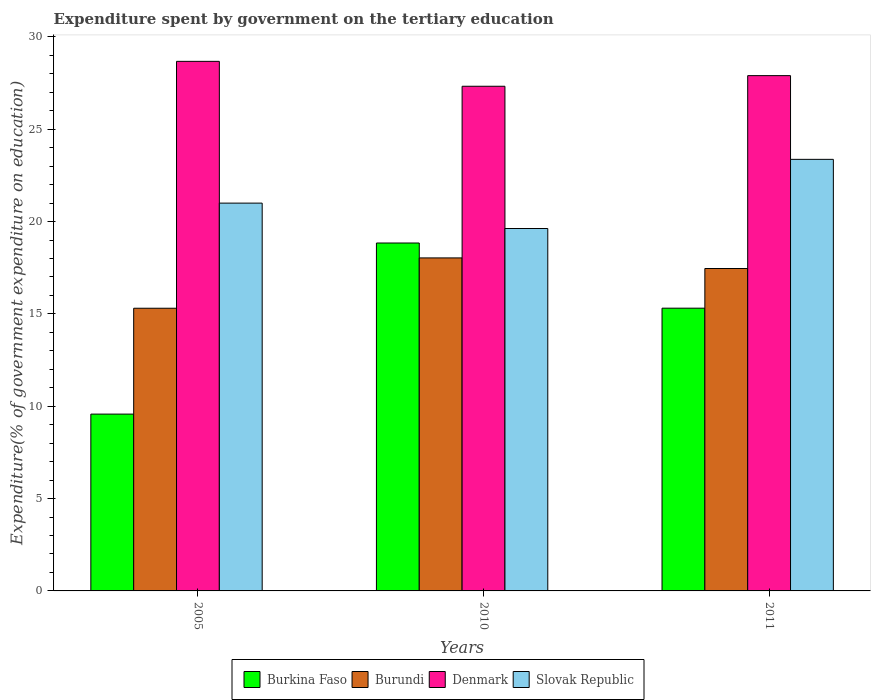How many different coloured bars are there?
Offer a very short reply. 4. Are the number of bars per tick equal to the number of legend labels?
Provide a succinct answer. Yes. Are the number of bars on each tick of the X-axis equal?
Provide a succinct answer. Yes. What is the label of the 2nd group of bars from the left?
Provide a succinct answer. 2010. What is the expenditure spent by government on the tertiary education in Burundi in 2011?
Your response must be concise. 17.46. Across all years, what is the maximum expenditure spent by government on the tertiary education in Slovak Republic?
Provide a short and direct response. 23.37. Across all years, what is the minimum expenditure spent by government on the tertiary education in Denmark?
Offer a very short reply. 27.33. What is the total expenditure spent by government on the tertiary education in Burundi in the graph?
Your response must be concise. 50.8. What is the difference between the expenditure spent by government on the tertiary education in Denmark in 2005 and that in 2011?
Your answer should be compact. 0.77. What is the difference between the expenditure spent by government on the tertiary education in Burundi in 2011 and the expenditure spent by government on the tertiary education in Burkina Faso in 2005?
Offer a very short reply. 7.88. What is the average expenditure spent by government on the tertiary education in Denmark per year?
Your response must be concise. 27.97. In the year 2011, what is the difference between the expenditure spent by government on the tertiary education in Denmark and expenditure spent by government on the tertiary education in Burkina Faso?
Ensure brevity in your answer.  12.59. In how many years, is the expenditure spent by government on the tertiary education in Burkina Faso greater than 5 %?
Your answer should be compact. 3. What is the ratio of the expenditure spent by government on the tertiary education in Burkina Faso in 2005 to that in 2010?
Provide a short and direct response. 0.51. Is the expenditure spent by government on the tertiary education in Denmark in 2005 less than that in 2010?
Provide a succinct answer. No. What is the difference between the highest and the second highest expenditure spent by government on the tertiary education in Slovak Republic?
Ensure brevity in your answer.  2.37. What is the difference between the highest and the lowest expenditure spent by government on the tertiary education in Slovak Republic?
Make the answer very short. 3.74. In how many years, is the expenditure spent by government on the tertiary education in Slovak Republic greater than the average expenditure spent by government on the tertiary education in Slovak Republic taken over all years?
Provide a short and direct response. 1. Is the sum of the expenditure spent by government on the tertiary education in Denmark in 2005 and 2011 greater than the maximum expenditure spent by government on the tertiary education in Burkina Faso across all years?
Offer a terse response. Yes. What does the 2nd bar from the left in 2010 represents?
Ensure brevity in your answer.  Burundi. What does the 4th bar from the right in 2011 represents?
Give a very brief answer. Burkina Faso. Is it the case that in every year, the sum of the expenditure spent by government on the tertiary education in Burkina Faso and expenditure spent by government on the tertiary education in Denmark is greater than the expenditure spent by government on the tertiary education in Slovak Republic?
Your answer should be very brief. Yes. How many years are there in the graph?
Give a very brief answer. 3. What is the difference between two consecutive major ticks on the Y-axis?
Ensure brevity in your answer.  5. Does the graph contain grids?
Your answer should be very brief. No. How many legend labels are there?
Offer a terse response. 4. How are the legend labels stacked?
Keep it short and to the point. Horizontal. What is the title of the graph?
Your answer should be very brief. Expenditure spent by government on the tertiary education. What is the label or title of the Y-axis?
Your answer should be compact. Expenditure(% of government expenditure on education). What is the Expenditure(% of government expenditure on education) in Burkina Faso in 2005?
Give a very brief answer. 9.58. What is the Expenditure(% of government expenditure on education) in Burundi in 2005?
Your response must be concise. 15.31. What is the Expenditure(% of government expenditure on education) in Denmark in 2005?
Ensure brevity in your answer.  28.68. What is the Expenditure(% of government expenditure on education) in Slovak Republic in 2005?
Your answer should be compact. 21. What is the Expenditure(% of government expenditure on education) in Burkina Faso in 2010?
Make the answer very short. 18.84. What is the Expenditure(% of government expenditure on education) of Burundi in 2010?
Your answer should be compact. 18.03. What is the Expenditure(% of government expenditure on education) of Denmark in 2010?
Your response must be concise. 27.33. What is the Expenditure(% of government expenditure on education) of Slovak Republic in 2010?
Keep it short and to the point. 19.63. What is the Expenditure(% of government expenditure on education) in Burkina Faso in 2011?
Keep it short and to the point. 15.31. What is the Expenditure(% of government expenditure on education) in Burundi in 2011?
Your response must be concise. 17.46. What is the Expenditure(% of government expenditure on education) of Denmark in 2011?
Give a very brief answer. 27.9. What is the Expenditure(% of government expenditure on education) of Slovak Republic in 2011?
Offer a terse response. 23.37. Across all years, what is the maximum Expenditure(% of government expenditure on education) in Burkina Faso?
Your response must be concise. 18.84. Across all years, what is the maximum Expenditure(% of government expenditure on education) in Burundi?
Your answer should be compact. 18.03. Across all years, what is the maximum Expenditure(% of government expenditure on education) of Denmark?
Your answer should be very brief. 28.68. Across all years, what is the maximum Expenditure(% of government expenditure on education) in Slovak Republic?
Make the answer very short. 23.37. Across all years, what is the minimum Expenditure(% of government expenditure on education) in Burkina Faso?
Offer a terse response. 9.58. Across all years, what is the minimum Expenditure(% of government expenditure on education) of Burundi?
Your answer should be compact. 15.31. Across all years, what is the minimum Expenditure(% of government expenditure on education) in Denmark?
Make the answer very short. 27.33. Across all years, what is the minimum Expenditure(% of government expenditure on education) of Slovak Republic?
Your response must be concise. 19.63. What is the total Expenditure(% of government expenditure on education) of Burkina Faso in the graph?
Your answer should be compact. 43.73. What is the total Expenditure(% of government expenditure on education) in Burundi in the graph?
Offer a terse response. 50.8. What is the total Expenditure(% of government expenditure on education) of Denmark in the graph?
Provide a short and direct response. 83.91. What is the total Expenditure(% of government expenditure on education) in Slovak Republic in the graph?
Give a very brief answer. 64. What is the difference between the Expenditure(% of government expenditure on education) of Burkina Faso in 2005 and that in 2010?
Provide a succinct answer. -9.27. What is the difference between the Expenditure(% of government expenditure on education) in Burundi in 2005 and that in 2010?
Offer a very short reply. -2.73. What is the difference between the Expenditure(% of government expenditure on education) of Denmark in 2005 and that in 2010?
Provide a succinct answer. 1.35. What is the difference between the Expenditure(% of government expenditure on education) of Slovak Republic in 2005 and that in 2010?
Your answer should be compact. 1.38. What is the difference between the Expenditure(% of government expenditure on education) of Burkina Faso in 2005 and that in 2011?
Provide a short and direct response. -5.74. What is the difference between the Expenditure(% of government expenditure on education) of Burundi in 2005 and that in 2011?
Your answer should be compact. -2.15. What is the difference between the Expenditure(% of government expenditure on education) in Denmark in 2005 and that in 2011?
Keep it short and to the point. 0.77. What is the difference between the Expenditure(% of government expenditure on education) in Slovak Republic in 2005 and that in 2011?
Offer a terse response. -2.37. What is the difference between the Expenditure(% of government expenditure on education) in Burkina Faso in 2010 and that in 2011?
Keep it short and to the point. 3.53. What is the difference between the Expenditure(% of government expenditure on education) in Burundi in 2010 and that in 2011?
Ensure brevity in your answer.  0.57. What is the difference between the Expenditure(% of government expenditure on education) of Denmark in 2010 and that in 2011?
Offer a very short reply. -0.58. What is the difference between the Expenditure(% of government expenditure on education) of Slovak Republic in 2010 and that in 2011?
Ensure brevity in your answer.  -3.74. What is the difference between the Expenditure(% of government expenditure on education) in Burkina Faso in 2005 and the Expenditure(% of government expenditure on education) in Burundi in 2010?
Your answer should be very brief. -8.46. What is the difference between the Expenditure(% of government expenditure on education) in Burkina Faso in 2005 and the Expenditure(% of government expenditure on education) in Denmark in 2010?
Provide a short and direct response. -17.75. What is the difference between the Expenditure(% of government expenditure on education) of Burkina Faso in 2005 and the Expenditure(% of government expenditure on education) of Slovak Republic in 2010?
Keep it short and to the point. -10.05. What is the difference between the Expenditure(% of government expenditure on education) in Burundi in 2005 and the Expenditure(% of government expenditure on education) in Denmark in 2010?
Your answer should be very brief. -12.02. What is the difference between the Expenditure(% of government expenditure on education) in Burundi in 2005 and the Expenditure(% of government expenditure on education) in Slovak Republic in 2010?
Make the answer very short. -4.32. What is the difference between the Expenditure(% of government expenditure on education) of Denmark in 2005 and the Expenditure(% of government expenditure on education) of Slovak Republic in 2010?
Offer a terse response. 9.05. What is the difference between the Expenditure(% of government expenditure on education) of Burkina Faso in 2005 and the Expenditure(% of government expenditure on education) of Burundi in 2011?
Provide a succinct answer. -7.88. What is the difference between the Expenditure(% of government expenditure on education) of Burkina Faso in 2005 and the Expenditure(% of government expenditure on education) of Denmark in 2011?
Provide a succinct answer. -18.33. What is the difference between the Expenditure(% of government expenditure on education) of Burkina Faso in 2005 and the Expenditure(% of government expenditure on education) of Slovak Republic in 2011?
Give a very brief answer. -13.8. What is the difference between the Expenditure(% of government expenditure on education) in Burundi in 2005 and the Expenditure(% of government expenditure on education) in Denmark in 2011?
Provide a succinct answer. -12.6. What is the difference between the Expenditure(% of government expenditure on education) of Burundi in 2005 and the Expenditure(% of government expenditure on education) of Slovak Republic in 2011?
Your answer should be very brief. -8.06. What is the difference between the Expenditure(% of government expenditure on education) of Denmark in 2005 and the Expenditure(% of government expenditure on education) of Slovak Republic in 2011?
Your answer should be very brief. 5.31. What is the difference between the Expenditure(% of government expenditure on education) of Burkina Faso in 2010 and the Expenditure(% of government expenditure on education) of Burundi in 2011?
Your answer should be very brief. 1.38. What is the difference between the Expenditure(% of government expenditure on education) of Burkina Faso in 2010 and the Expenditure(% of government expenditure on education) of Denmark in 2011?
Make the answer very short. -9.06. What is the difference between the Expenditure(% of government expenditure on education) of Burkina Faso in 2010 and the Expenditure(% of government expenditure on education) of Slovak Republic in 2011?
Offer a terse response. -4.53. What is the difference between the Expenditure(% of government expenditure on education) of Burundi in 2010 and the Expenditure(% of government expenditure on education) of Denmark in 2011?
Give a very brief answer. -9.87. What is the difference between the Expenditure(% of government expenditure on education) of Burundi in 2010 and the Expenditure(% of government expenditure on education) of Slovak Republic in 2011?
Your response must be concise. -5.34. What is the difference between the Expenditure(% of government expenditure on education) in Denmark in 2010 and the Expenditure(% of government expenditure on education) in Slovak Republic in 2011?
Provide a short and direct response. 3.96. What is the average Expenditure(% of government expenditure on education) in Burkina Faso per year?
Make the answer very short. 14.58. What is the average Expenditure(% of government expenditure on education) of Burundi per year?
Offer a terse response. 16.93. What is the average Expenditure(% of government expenditure on education) of Denmark per year?
Your response must be concise. 27.97. What is the average Expenditure(% of government expenditure on education) of Slovak Republic per year?
Keep it short and to the point. 21.33. In the year 2005, what is the difference between the Expenditure(% of government expenditure on education) of Burkina Faso and Expenditure(% of government expenditure on education) of Burundi?
Offer a terse response. -5.73. In the year 2005, what is the difference between the Expenditure(% of government expenditure on education) of Burkina Faso and Expenditure(% of government expenditure on education) of Denmark?
Give a very brief answer. -19.1. In the year 2005, what is the difference between the Expenditure(% of government expenditure on education) in Burkina Faso and Expenditure(% of government expenditure on education) in Slovak Republic?
Provide a succinct answer. -11.43. In the year 2005, what is the difference between the Expenditure(% of government expenditure on education) of Burundi and Expenditure(% of government expenditure on education) of Denmark?
Your answer should be very brief. -13.37. In the year 2005, what is the difference between the Expenditure(% of government expenditure on education) of Burundi and Expenditure(% of government expenditure on education) of Slovak Republic?
Make the answer very short. -5.69. In the year 2005, what is the difference between the Expenditure(% of government expenditure on education) in Denmark and Expenditure(% of government expenditure on education) in Slovak Republic?
Your answer should be compact. 7.68. In the year 2010, what is the difference between the Expenditure(% of government expenditure on education) in Burkina Faso and Expenditure(% of government expenditure on education) in Burundi?
Your response must be concise. 0.81. In the year 2010, what is the difference between the Expenditure(% of government expenditure on education) in Burkina Faso and Expenditure(% of government expenditure on education) in Denmark?
Keep it short and to the point. -8.49. In the year 2010, what is the difference between the Expenditure(% of government expenditure on education) of Burkina Faso and Expenditure(% of government expenditure on education) of Slovak Republic?
Provide a succinct answer. -0.79. In the year 2010, what is the difference between the Expenditure(% of government expenditure on education) of Burundi and Expenditure(% of government expenditure on education) of Denmark?
Your response must be concise. -9.3. In the year 2010, what is the difference between the Expenditure(% of government expenditure on education) in Burundi and Expenditure(% of government expenditure on education) in Slovak Republic?
Make the answer very short. -1.59. In the year 2010, what is the difference between the Expenditure(% of government expenditure on education) in Denmark and Expenditure(% of government expenditure on education) in Slovak Republic?
Provide a succinct answer. 7.7. In the year 2011, what is the difference between the Expenditure(% of government expenditure on education) in Burkina Faso and Expenditure(% of government expenditure on education) in Burundi?
Your response must be concise. -2.15. In the year 2011, what is the difference between the Expenditure(% of government expenditure on education) of Burkina Faso and Expenditure(% of government expenditure on education) of Denmark?
Your answer should be very brief. -12.59. In the year 2011, what is the difference between the Expenditure(% of government expenditure on education) of Burkina Faso and Expenditure(% of government expenditure on education) of Slovak Republic?
Your answer should be very brief. -8.06. In the year 2011, what is the difference between the Expenditure(% of government expenditure on education) in Burundi and Expenditure(% of government expenditure on education) in Denmark?
Offer a terse response. -10.44. In the year 2011, what is the difference between the Expenditure(% of government expenditure on education) in Burundi and Expenditure(% of government expenditure on education) in Slovak Republic?
Offer a very short reply. -5.91. In the year 2011, what is the difference between the Expenditure(% of government expenditure on education) in Denmark and Expenditure(% of government expenditure on education) in Slovak Republic?
Your response must be concise. 4.53. What is the ratio of the Expenditure(% of government expenditure on education) of Burkina Faso in 2005 to that in 2010?
Your answer should be very brief. 0.51. What is the ratio of the Expenditure(% of government expenditure on education) of Burundi in 2005 to that in 2010?
Ensure brevity in your answer.  0.85. What is the ratio of the Expenditure(% of government expenditure on education) of Denmark in 2005 to that in 2010?
Offer a terse response. 1.05. What is the ratio of the Expenditure(% of government expenditure on education) of Slovak Republic in 2005 to that in 2010?
Give a very brief answer. 1.07. What is the ratio of the Expenditure(% of government expenditure on education) in Burkina Faso in 2005 to that in 2011?
Make the answer very short. 0.63. What is the ratio of the Expenditure(% of government expenditure on education) in Burundi in 2005 to that in 2011?
Keep it short and to the point. 0.88. What is the ratio of the Expenditure(% of government expenditure on education) of Denmark in 2005 to that in 2011?
Your answer should be very brief. 1.03. What is the ratio of the Expenditure(% of government expenditure on education) of Slovak Republic in 2005 to that in 2011?
Offer a terse response. 0.9. What is the ratio of the Expenditure(% of government expenditure on education) of Burkina Faso in 2010 to that in 2011?
Give a very brief answer. 1.23. What is the ratio of the Expenditure(% of government expenditure on education) in Burundi in 2010 to that in 2011?
Provide a short and direct response. 1.03. What is the ratio of the Expenditure(% of government expenditure on education) of Denmark in 2010 to that in 2011?
Your answer should be compact. 0.98. What is the ratio of the Expenditure(% of government expenditure on education) in Slovak Republic in 2010 to that in 2011?
Offer a terse response. 0.84. What is the difference between the highest and the second highest Expenditure(% of government expenditure on education) of Burkina Faso?
Offer a terse response. 3.53. What is the difference between the highest and the second highest Expenditure(% of government expenditure on education) of Burundi?
Give a very brief answer. 0.57. What is the difference between the highest and the second highest Expenditure(% of government expenditure on education) in Denmark?
Keep it short and to the point. 0.77. What is the difference between the highest and the second highest Expenditure(% of government expenditure on education) of Slovak Republic?
Give a very brief answer. 2.37. What is the difference between the highest and the lowest Expenditure(% of government expenditure on education) in Burkina Faso?
Give a very brief answer. 9.27. What is the difference between the highest and the lowest Expenditure(% of government expenditure on education) of Burundi?
Keep it short and to the point. 2.73. What is the difference between the highest and the lowest Expenditure(% of government expenditure on education) in Denmark?
Ensure brevity in your answer.  1.35. What is the difference between the highest and the lowest Expenditure(% of government expenditure on education) in Slovak Republic?
Offer a terse response. 3.74. 